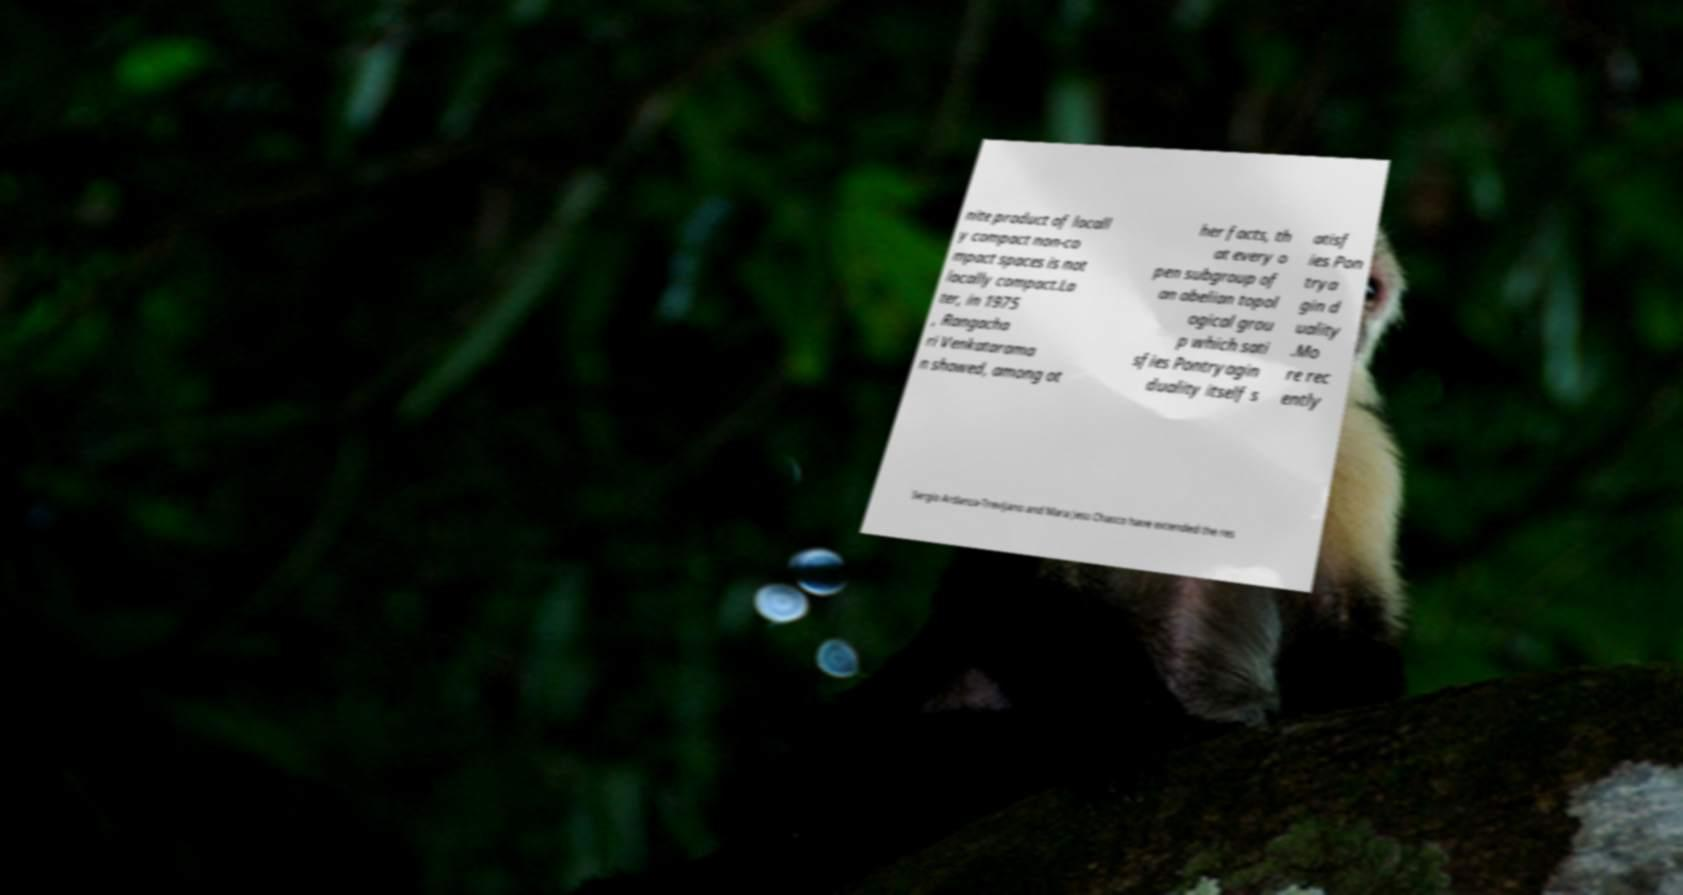Could you extract and type out the text from this image? nite product of locall y compact non-co mpact spaces is not locally compact.La ter, in 1975 , Rangacha ri Venkatarama n showed, among ot her facts, th at every o pen subgroup of an abelian topol ogical grou p which sati sfies Pontryagin duality itself s atisf ies Pon trya gin d uality .Mo re rec ently Sergio Ardanza-Trevijano and Mara Jess Chasco have extended the res 